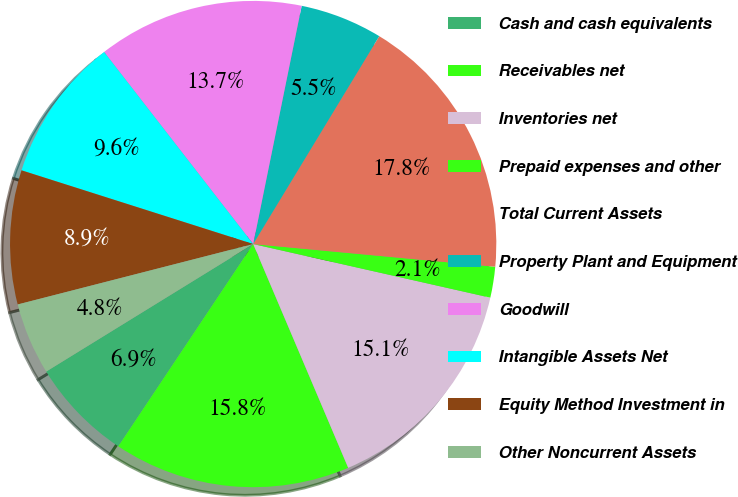<chart> <loc_0><loc_0><loc_500><loc_500><pie_chart><fcel>Cash and cash equivalents<fcel>Receivables net<fcel>Inventories net<fcel>Prepaid expenses and other<fcel>Total Current Assets<fcel>Property Plant and Equipment<fcel>Goodwill<fcel>Intangible Assets Net<fcel>Equity Method Investment in<fcel>Other Noncurrent Assets<nl><fcel>6.85%<fcel>15.75%<fcel>15.07%<fcel>2.05%<fcel>17.81%<fcel>5.48%<fcel>13.7%<fcel>9.59%<fcel>8.9%<fcel>4.79%<nl></chart> 